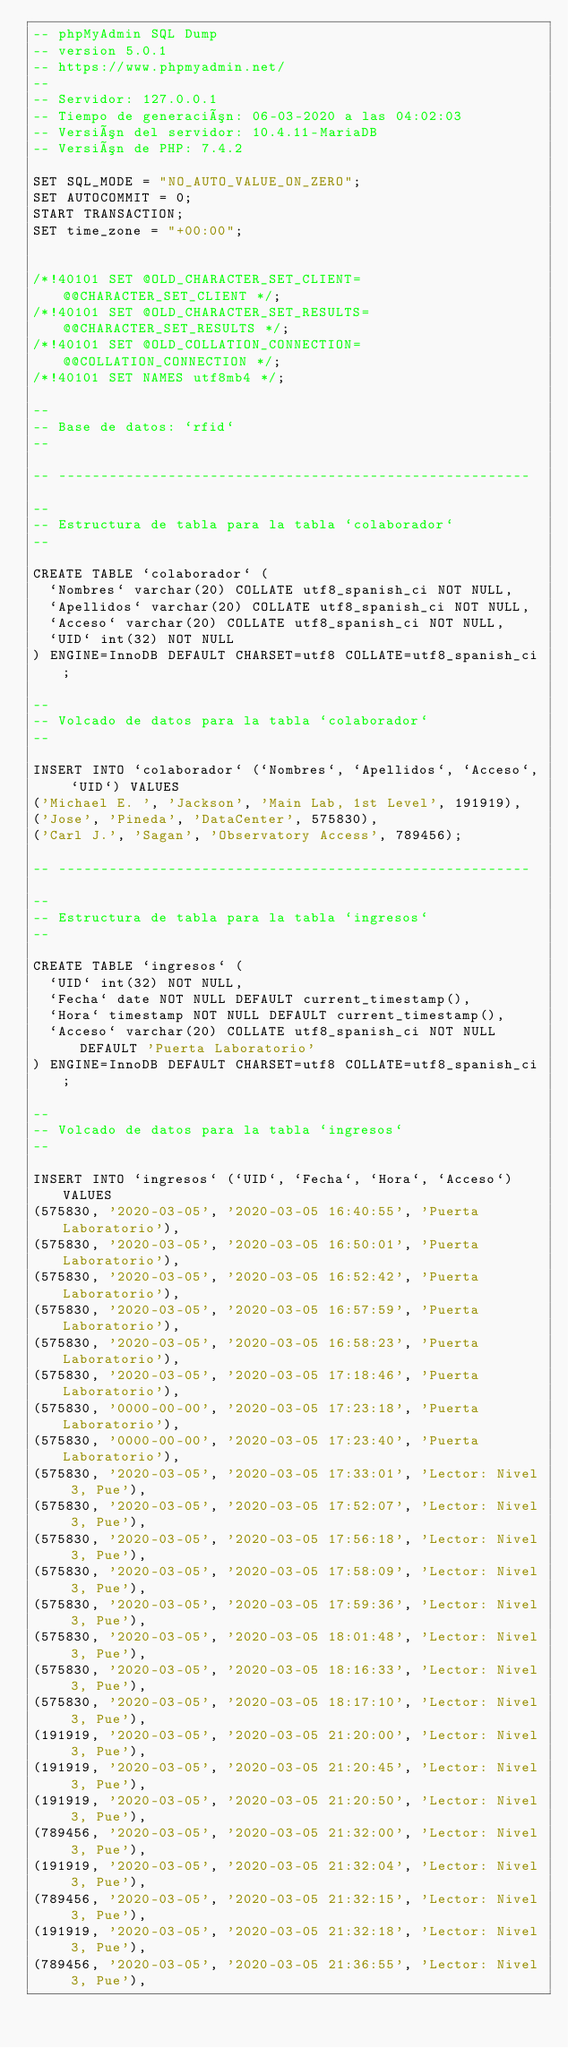Convert code to text. <code><loc_0><loc_0><loc_500><loc_500><_SQL_>-- phpMyAdmin SQL Dump
-- version 5.0.1
-- https://www.phpmyadmin.net/
--
-- Servidor: 127.0.0.1
-- Tiempo de generación: 06-03-2020 a las 04:02:03
-- Versión del servidor: 10.4.11-MariaDB
-- Versión de PHP: 7.4.2

SET SQL_MODE = "NO_AUTO_VALUE_ON_ZERO";
SET AUTOCOMMIT = 0;
START TRANSACTION;
SET time_zone = "+00:00";


/*!40101 SET @OLD_CHARACTER_SET_CLIENT=@@CHARACTER_SET_CLIENT */;
/*!40101 SET @OLD_CHARACTER_SET_RESULTS=@@CHARACTER_SET_RESULTS */;
/*!40101 SET @OLD_COLLATION_CONNECTION=@@COLLATION_CONNECTION */;
/*!40101 SET NAMES utf8mb4 */;

--
-- Base de datos: `rfid`
--

-- --------------------------------------------------------

--
-- Estructura de tabla para la tabla `colaborador`
--

CREATE TABLE `colaborador` (
  `Nombres` varchar(20) COLLATE utf8_spanish_ci NOT NULL,
  `Apellidos` varchar(20) COLLATE utf8_spanish_ci NOT NULL,
  `Acceso` varchar(20) COLLATE utf8_spanish_ci NOT NULL,
  `UID` int(32) NOT NULL
) ENGINE=InnoDB DEFAULT CHARSET=utf8 COLLATE=utf8_spanish_ci;

--
-- Volcado de datos para la tabla `colaborador`
--

INSERT INTO `colaborador` (`Nombres`, `Apellidos`, `Acceso`, `UID`) VALUES
('Michael E. ', 'Jackson', 'Main Lab, 1st Level', 191919),
('Jose', 'Pineda', 'DataCenter', 575830),
('Carl J.', 'Sagan', 'Observatory Access', 789456);

-- --------------------------------------------------------

--
-- Estructura de tabla para la tabla `ingresos`
--

CREATE TABLE `ingresos` (
  `UID` int(32) NOT NULL,
  `Fecha` date NOT NULL DEFAULT current_timestamp(),
  `Hora` timestamp NOT NULL DEFAULT current_timestamp(),
  `Acceso` varchar(20) COLLATE utf8_spanish_ci NOT NULL DEFAULT 'Puerta Laboratorio'
) ENGINE=InnoDB DEFAULT CHARSET=utf8 COLLATE=utf8_spanish_ci;

--
-- Volcado de datos para la tabla `ingresos`
--

INSERT INTO `ingresos` (`UID`, `Fecha`, `Hora`, `Acceso`) VALUES
(575830, '2020-03-05', '2020-03-05 16:40:55', 'Puerta Laboratorio'),
(575830, '2020-03-05', '2020-03-05 16:50:01', 'Puerta Laboratorio'),
(575830, '2020-03-05', '2020-03-05 16:52:42', 'Puerta Laboratorio'),
(575830, '2020-03-05', '2020-03-05 16:57:59', 'Puerta Laboratorio'),
(575830, '2020-03-05', '2020-03-05 16:58:23', 'Puerta Laboratorio'),
(575830, '2020-03-05', '2020-03-05 17:18:46', 'Puerta Laboratorio'),
(575830, '0000-00-00', '2020-03-05 17:23:18', 'Puerta Laboratorio'),
(575830, '0000-00-00', '2020-03-05 17:23:40', 'Puerta Laboratorio'),
(575830, '2020-03-05', '2020-03-05 17:33:01', 'Lector: Nivel 3, Pue'),
(575830, '2020-03-05', '2020-03-05 17:52:07', 'Lector: Nivel 3, Pue'),
(575830, '2020-03-05', '2020-03-05 17:56:18', 'Lector: Nivel 3, Pue'),
(575830, '2020-03-05', '2020-03-05 17:58:09', 'Lector: Nivel 3, Pue'),
(575830, '2020-03-05', '2020-03-05 17:59:36', 'Lector: Nivel 3, Pue'),
(575830, '2020-03-05', '2020-03-05 18:01:48', 'Lector: Nivel 3, Pue'),
(575830, '2020-03-05', '2020-03-05 18:16:33', 'Lector: Nivel 3, Pue'),
(575830, '2020-03-05', '2020-03-05 18:17:10', 'Lector: Nivel 3, Pue'),
(191919, '2020-03-05', '2020-03-05 21:20:00', 'Lector: Nivel 3, Pue'),
(191919, '2020-03-05', '2020-03-05 21:20:45', 'Lector: Nivel 3, Pue'),
(191919, '2020-03-05', '2020-03-05 21:20:50', 'Lector: Nivel 3, Pue'),
(789456, '2020-03-05', '2020-03-05 21:32:00', 'Lector: Nivel 3, Pue'),
(191919, '2020-03-05', '2020-03-05 21:32:04', 'Lector: Nivel 3, Pue'),
(789456, '2020-03-05', '2020-03-05 21:32:15', 'Lector: Nivel 3, Pue'),
(191919, '2020-03-05', '2020-03-05 21:32:18', 'Lector: Nivel 3, Pue'),
(789456, '2020-03-05', '2020-03-05 21:36:55', 'Lector: Nivel 3, Pue'),</code> 